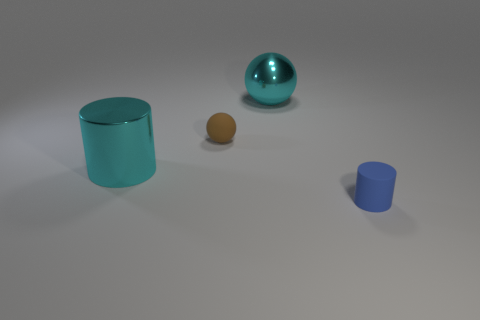What is the shape of the blue thing that is made of the same material as the tiny ball?
Your answer should be very brief. Cylinder. There is a rubber thing left of the small cylinder; are there any tiny brown matte objects that are to the right of it?
Your answer should be very brief. No. Are there any other things that have the same shape as the brown rubber object?
Your answer should be compact. Yes. There is a big shiny thing that is the same shape as the small brown object; what is its color?
Provide a succinct answer. Cyan. What is the size of the rubber sphere?
Ensure brevity in your answer.  Small. Are there fewer brown rubber objects that are on the left side of the large shiny cylinder than tiny spheres?
Provide a short and direct response. Yes. Do the cyan ball and the cylinder that is behind the blue object have the same material?
Ensure brevity in your answer.  Yes. There is a cyan thing to the right of the large cyan thing left of the brown rubber object; is there a thing that is behind it?
Your answer should be compact. No. Is there anything else that has the same size as the metallic ball?
Give a very brief answer. Yes. There is a thing that is made of the same material as the brown sphere; what is its color?
Your answer should be compact. Blue. 